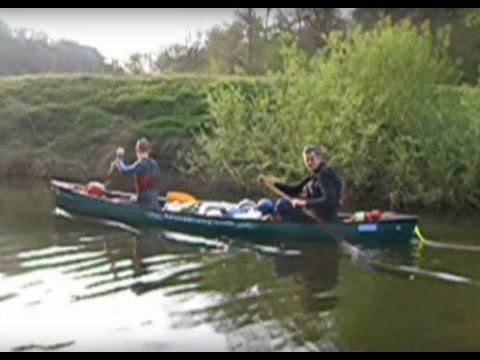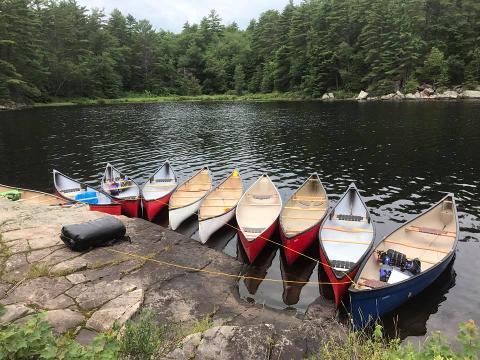The first image is the image on the left, the second image is the image on the right. For the images displayed, is the sentence "There are exactly two canoes in the water." factually correct? Answer yes or no. No. The first image is the image on the left, the second image is the image on the right. For the images shown, is this caption "The left and right image contains the same number of boats facing left and forward." true? Answer yes or no. No. 